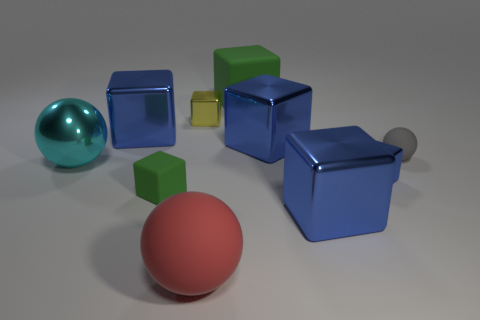What is the shape of the large green object that is made of the same material as the tiny gray object?
Provide a succinct answer. Cube. Is there anything else of the same color as the tiny rubber cube?
Your answer should be very brief. Yes. There is a metal thing that is left of the blue block to the left of the red ball; what color is it?
Offer a very short reply. Cyan. How many small things are either rubber balls or green matte cubes?
Give a very brief answer. 2. What is the material of the tiny green thing that is the same shape as the big green thing?
Your response must be concise. Rubber. Is there any other thing that has the same material as the large green cube?
Give a very brief answer. Yes. The large matte sphere is what color?
Provide a succinct answer. Red. Is the small rubber ball the same color as the small rubber cube?
Your answer should be very brief. No. How many large blue shiny blocks are to the right of the small shiny thing that is in front of the large cyan shiny ball?
Offer a terse response. 0. There is a matte thing that is in front of the large metallic sphere and on the right side of the small rubber cube; how big is it?
Your answer should be very brief. Large. 